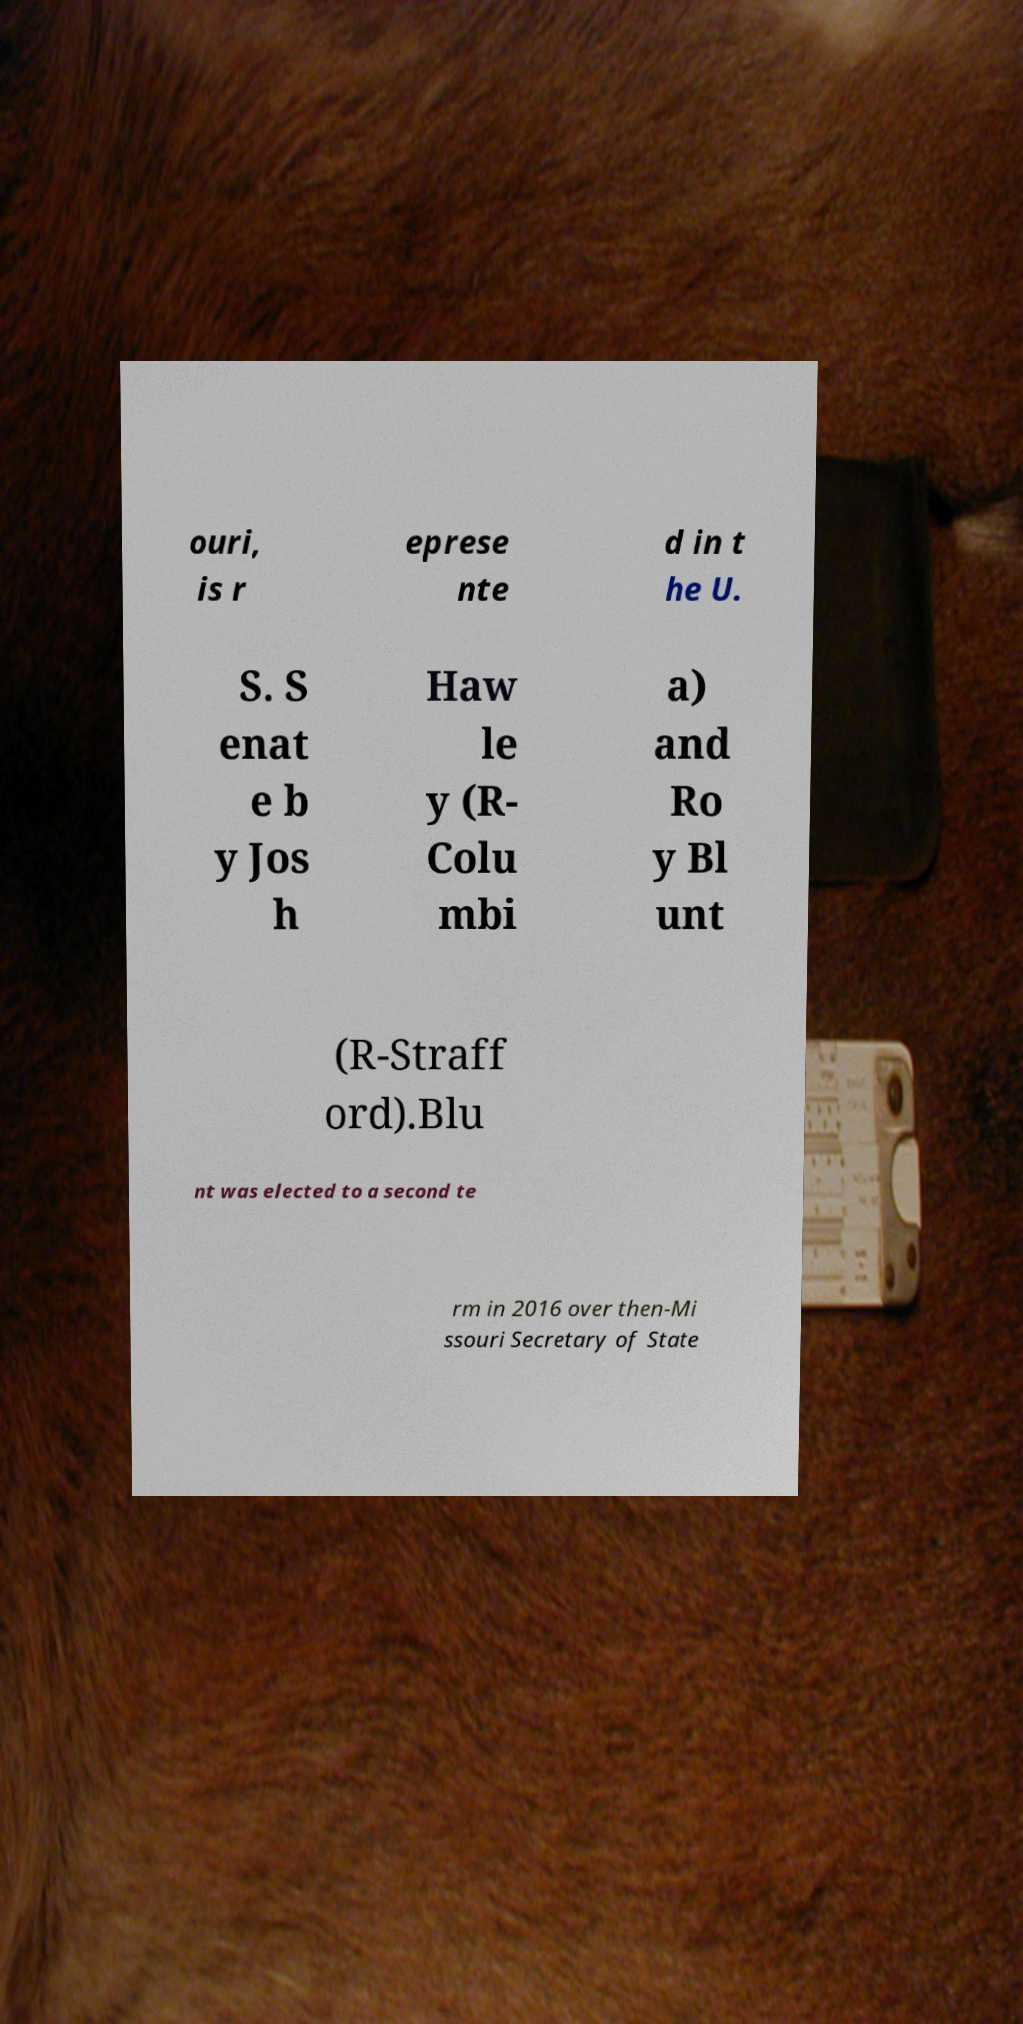For documentation purposes, I need the text within this image transcribed. Could you provide that? ouri, is r eprese nte d in t he U. S. S enat e b y Jos h Haw le y (R- Colu mbi a) and Ro y Bl unt (R-Straff ord).Blu nt was elected to a second te rm in 2016 over then-Mi ssouri Secretary of State 